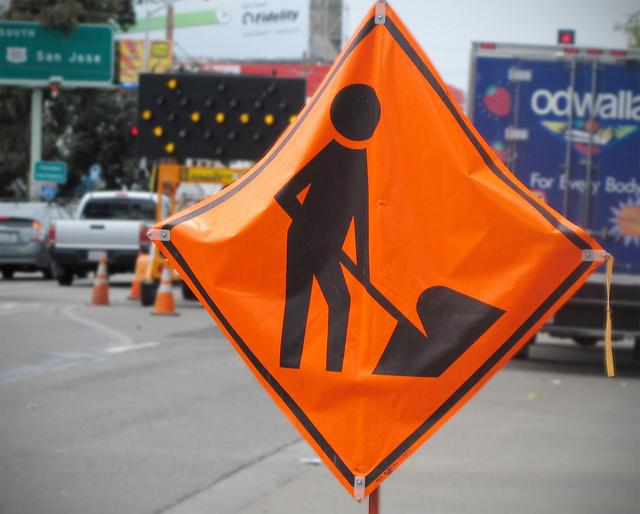What does the orange sign alert drivers of? construction 